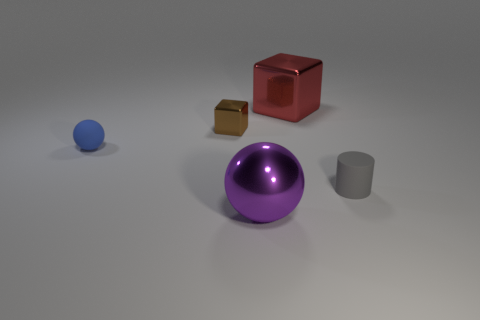Subtract 1 balls. How many balls are left? 1 Add 2 small brown metallic objects. How many objects exist? 7 Subtract all balls. How many objects are left? 3 Subtract all red balls. How many brown cubes are left? 1 Subtract all red blocks. Subtract all gray balls. How many blocks are left? 1 Subtract all big red metallic cubes. Subtract all rubber cylinders. How many objects are left? 3 Add 2 tiny matte objects. How many tiny matte objects are left? 4 Add 2 tiny gray objects. How many tiny gray objects exist? 3 Subtract 0 yellow blocks. How many objects are left? 5 